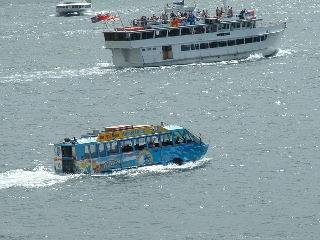Imagine a narrative that might be occurring on the larger boat. Who might be aboard, and what is their destination? On the larger ferry boat, one could imagine a group of commuters returning home after a day's work in the city, alongside tourists absorbing the coastal views. The air is filled with a mix of conversations, camera clicks, and the distant sound of seagulls. As the ferry glides across the water, the passengers are likely heading towards a nearby island or the opposite shore, where the next leg of their journey awaits. 